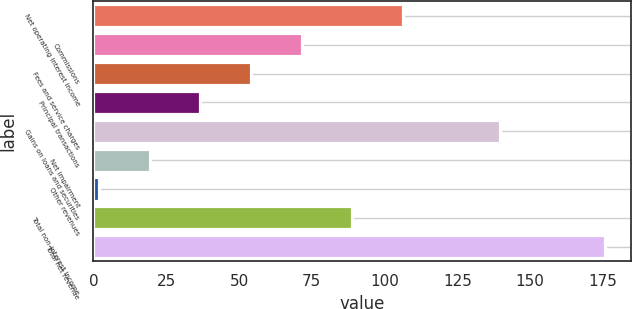Convert chart. <chart><loc_0><loc_0><loc_500><loc_500><bar_chart><fcel>Net operating interest income<fcel>Commissions<fcel>Fees and service charges<fcel>Principal transactions<fcel>Gains on loans and securities<fcel>Net impairment<fcel>Other revenues<fcel>Total non-interest income<fcel>Total net revenue<nl><fcel>106.28<fcel>71.52<fcel>54.14<fcel>36.76<fcel>139.8<fcel>19.38<fcel>2<fcel>88.9<fcel>175.8<nl></chart> 